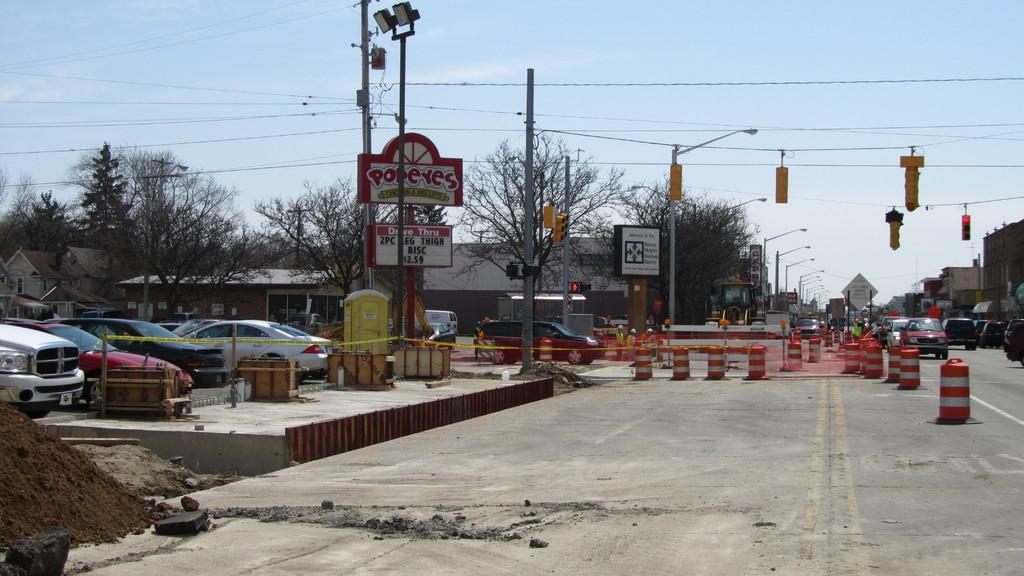<image>
Relay a brief, clear account of the picture shown. Street construction is taking place next to a Popeyes Restaurant. 